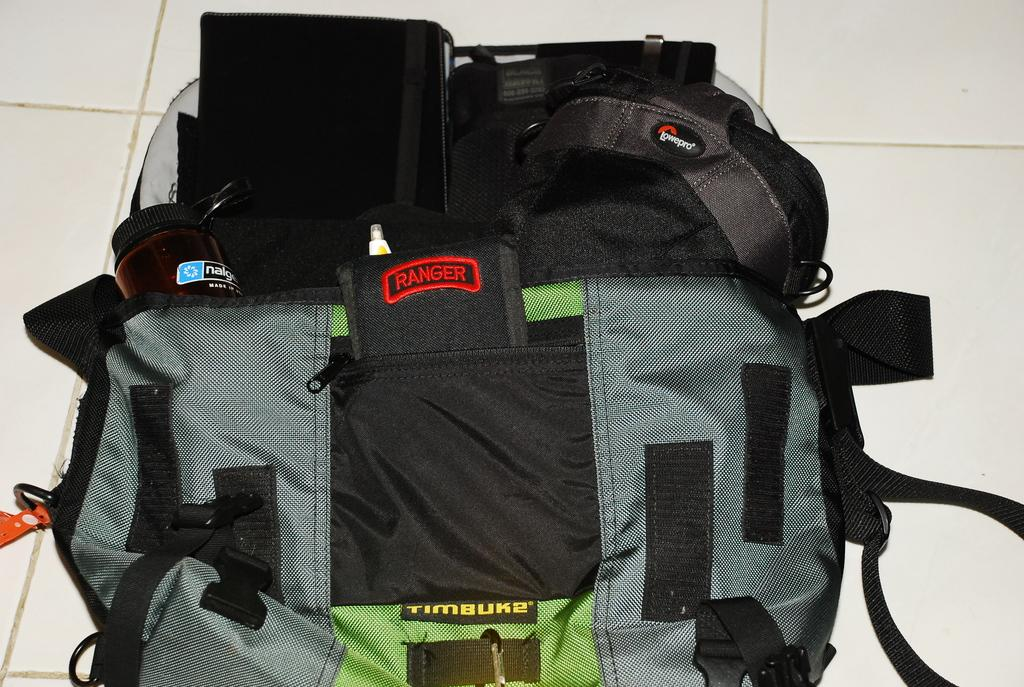What object in the image is typically used for carrying items? There is a bag in the image, which is typically used for carrying items. Where is the bottle located in the image? The bottle is located on the left side in the image. What type of cover is used to protect the bag in the image? There is no mention of a cover for the bag in the image. What is the texture of the bottle in the image? The texture of the bottle cannot be determined from the image alone. 